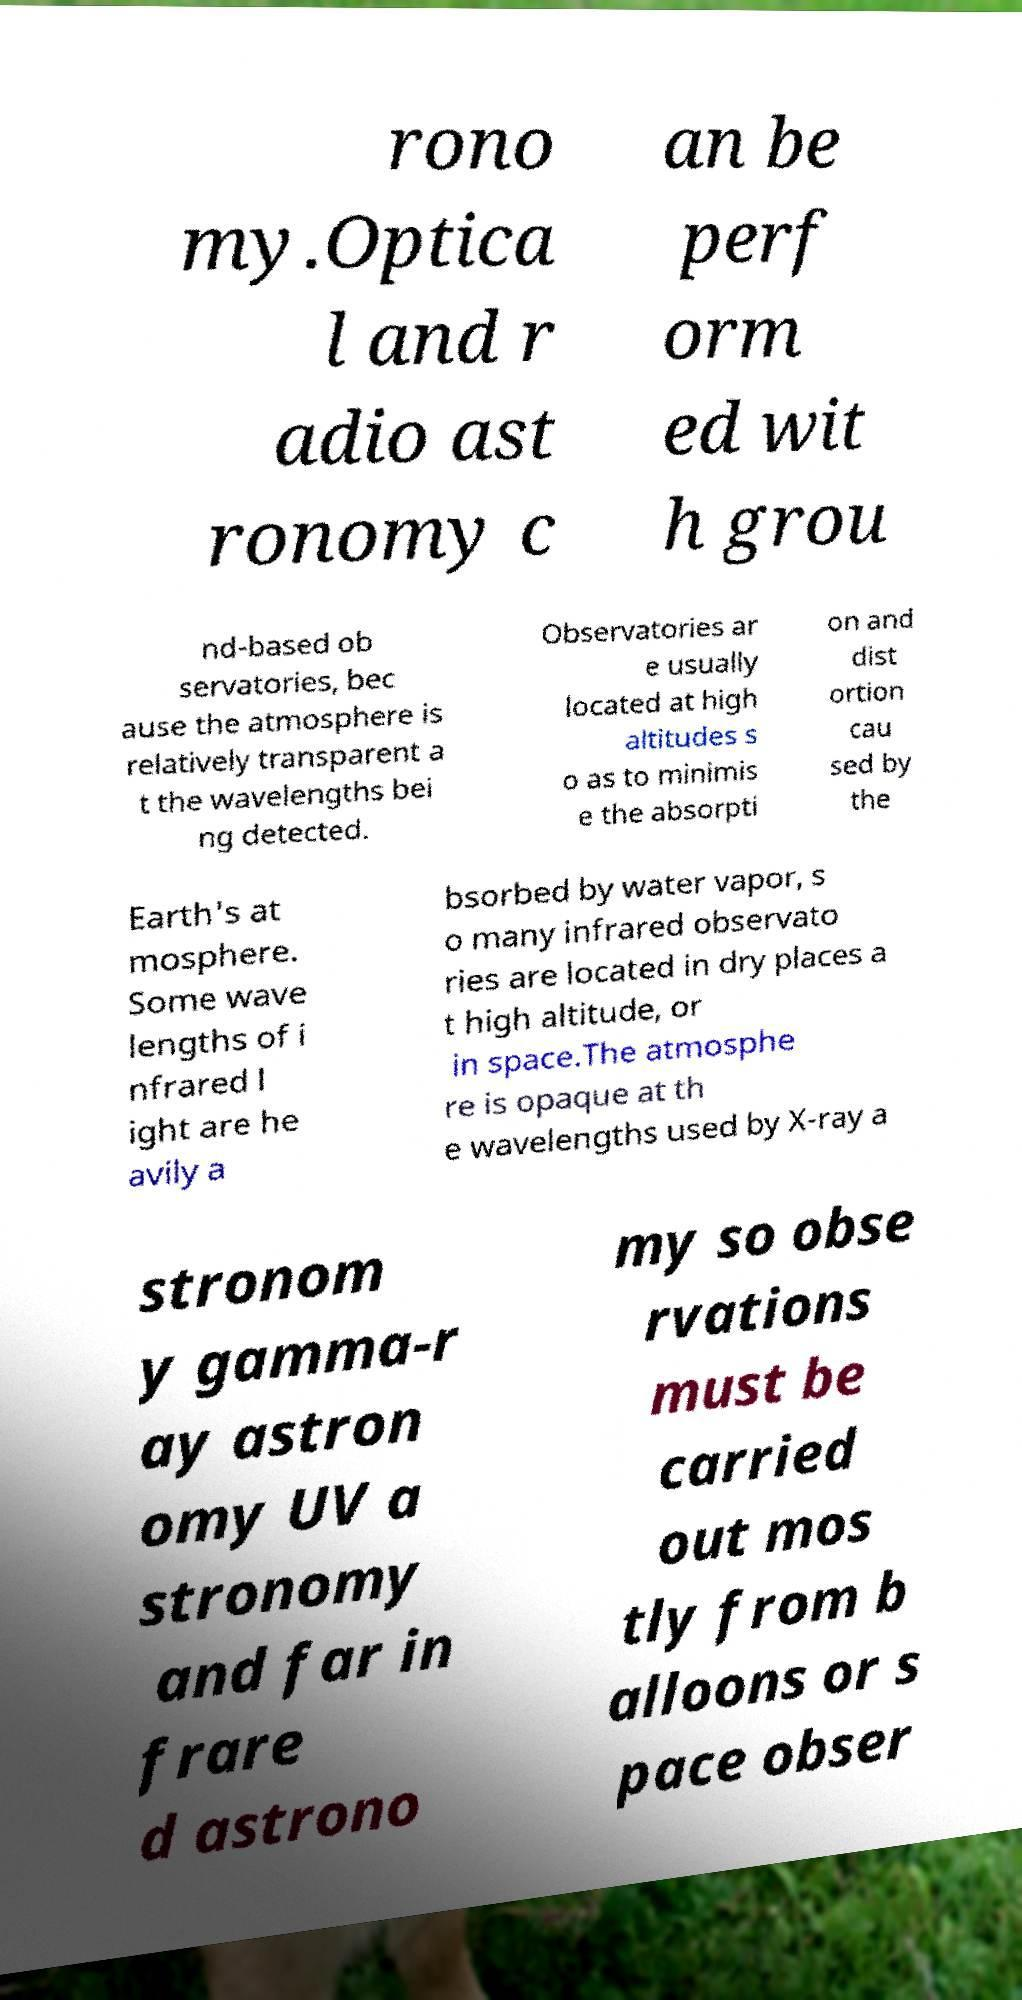Can you read and provide the text displayed in the image?This photo seems to have some interesting text. Can you extract and type it out for me? rono my.Optica l and r adio ast ronomy c an be perf orm ed wit h grou nd-based ob servatories, bec ause the atmosphere is relatively transparent a t the wavelengths bei ng detected. Observatories ar e usually located at high altitudes s o as to minimis e the absorpti on and dist ortion cau sed by the Earth's at mosphere. Some wave lengths of i nfrared l ight are he avily a bsorbed by water vapor, s o many infrared observato ries are located in dry places a t high altitude, or in space.The atmosphe re is opaque at th e wavelengths used by X-ray a stronom y gamma-r ay astron omy UV a stronomy and far in frare d astrono my so obse rvations must be carried out mos tly from b alloons or s pace obser 